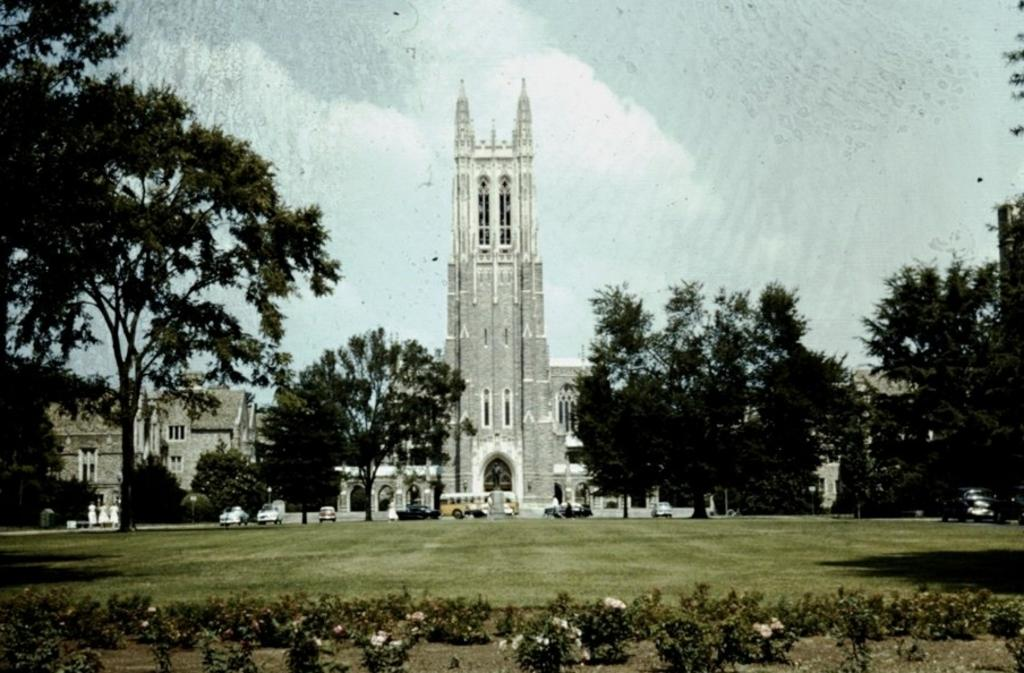What type of structures can be seen in the image? There are buildings in the image. What mode of transportation can be seen in the image? Motor vehicles are present in the image. What type of waste disposal containers are visible in the image? Bins are visible in the image. What type of seating is available in the image? Benches are in the image. What type of vegetation is present in the image? Trees are present in the image. What part of the natural environment is visible in the image? The ground is visible in the image. What part of the natural environment is visible in the sky? The sky is visible in the image, and clouds are present in the sky. What type of vegetation is present near the ground? Bushes are visible in the image. What type of terrain is present in the image? Mud is present in the image. How does the image feel when you walk through it? The image is a static representation and cannot be physically walked through. What thoughts are present in the mind of the person who took the image? The thoughts of the person who took the image are not visible in the image and cannot be determined. 